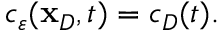Convert formula to latex. <formula><loc_0><loc_0><loc_500><loc_500>\begin{array} { r } { c _ { \varepsilon } ( \mathbf x _ { D } , t ) = c _ { D } ( t ) . } \end{array}</formula> 